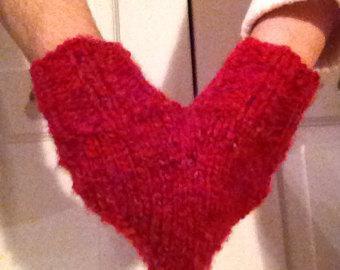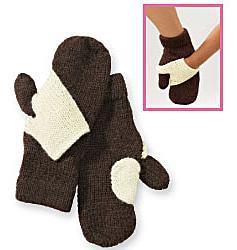The first image is the image on the left, the second image is the image on the right. Assess this claim about the two images: "An image shows a pair of hands in joined red mittens that form a heart shape when worn.". Correct or not? Answer yes or no. Yes. 